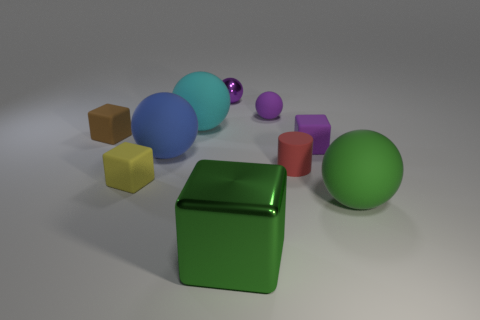Is there anything else that has the same shape as the small red thing?
Offer a very short reply. No. Do the shiny object behind the big blue matte object and the tiny purple matte thing in front of the tiny brown matte object have the same shape?
Your answer should be very brief. No. What number of other objects are there of the same material as the blue sphere?
Keep it short and to the point. 7. Does the small cube that is in front of the blue rubber object have the same material as the purple object that is in front of the small brown rubber object?
Offer a terse response. Yes. What shape is the cyan thing that is made of the same material as the yellow block?
Offer a terse response. Sphere. Are there any other things that have the same color as the large shiny block?
Offer a terse response. Yes. What number of big metallic objects are there?
Provide a short and direct response. 1. There is a big thing that is in front of the purple block and behind the big green rubber sphere; what shape is it?
Ensure brevity in your answer.  Sphere. The large object that is behind the small purple matte object that is to the right of the tiny purple ball that is right of the big green shiny object is what shape?
Give a very brief answer. Sphere. What material is the purple thing that is left of the purple cube and in front of the small metal object?
Offer a very short reply. Rubber. 